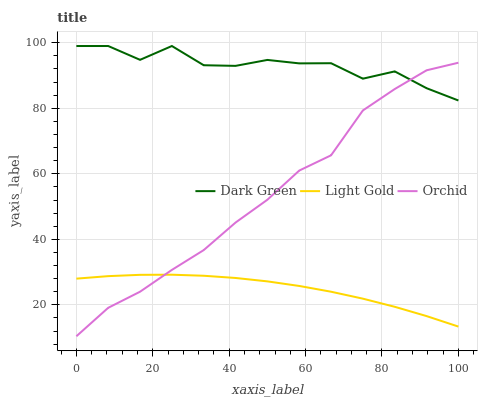Does Light Gold have the minimum area under the curve?
Answer yes or no. Yes. Does Dark Green have the maximum area under the curve?
Answer yes or no. Yes. Does Dark Green have the minimum area under the curve?
Answer yes or no. No. Does Light Gold have the maximum area under the curve?
Answer yes or no. No. Is Light Gold the smoothest?
Answer yes or no. Yes. Is Dark Green the roughest?
Answer yes or no. Yes. Is Dark Green the smoothest?
Answer yes or no. No. Is Light Gold the roughest?
Answer yes or no. No. Does Orchid have the lowest value?
Answer yes or no. Yes. Does Light Gold have the lowest value?
Answer yes or no. No. Does Dark Green have the highest value?
Answer yes or no. Yes. Does Light Gold have the highest value?
Answer yes or no. No. Is Light Gold less than Dark Green?
Answer yes or no. Yes. Is Dark Green greater than Light Gold?
Answer yes or no. Yes. Does Orchid intersect Light Gold?
Answer yes or no. Yes. Is Orchid less than Light Gold?
Answer yes or no. No. Is Orchid greater than Light Gold?
Answer yes or no. No. Does Light Gold intersect Dark Green?
Answer yes or no. No. 